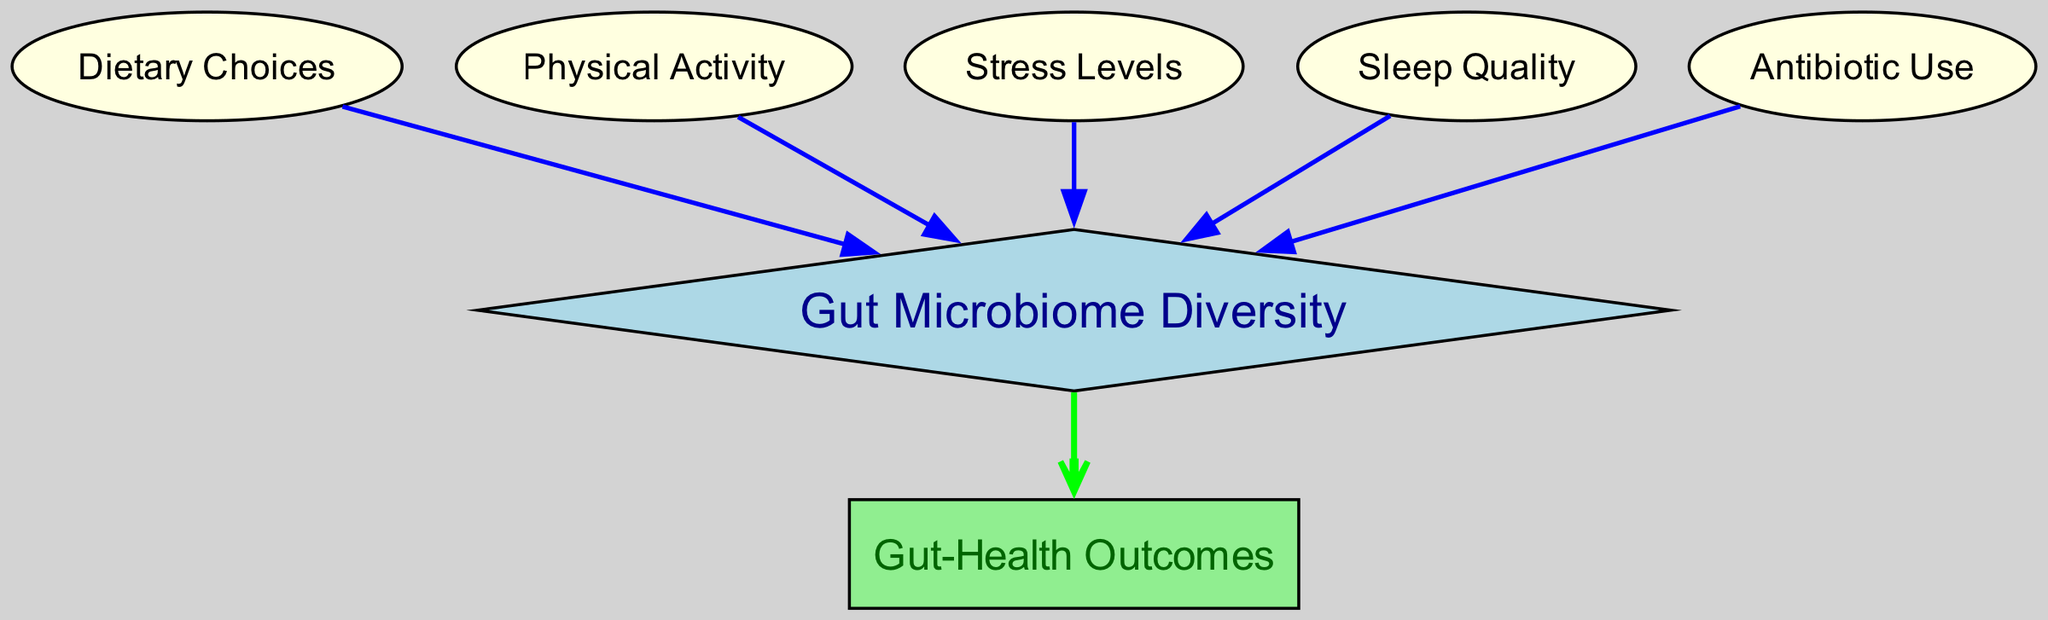What are the nodes in the diagram? The nodes in the diagram are Gut Microbiome Diversity, Dietary Choices, Physical Activity, Stress Levels, Sleep Quality, Antibiotic Use, and Gut-Health Outcomes.
Answer: Gut Microbiome Diversity, Dietary Choices, Physical Activity, Stress Levels, Sleep Quality, Antibiotic Use, Gut-Health Outcomes How many edges are present in the diagram? By counting the edges shown in the diagram, we find there are six connections made between the nodes.
Answer: 6 Which node affects Gut Microbiome Diversity the most? Since all nodes except Gut-Health Outcomes directly connect to Gut Microbiome Diversity, they all contribute equally to its diversity. However, reasoning through lifestyle factors suggests Diet choices likely have the most prominent impact.
Answer: Dietary Choices Which node is the output of Gut Microbiome Diversity? The edge directed away from Gut Microbiome Diversity leads to Gut-Health Outcomes, indicating the relationship where Gut Microbiome Diversity impacts Gut-Health Outcomes.
Answer: Gut-Health Outcomes How many lifestyle factors are considered in the diagram? There are four lifestyle factors displayed in the diagram, namely Dietary Choices, Physical Activity, Stress Levels, and Sleep Quality.
Answer: 4 What is the direction of influence from Antibiotic Use to Gut Microbiome Diversity? The influence is directed from Antibiotic Use to Gut Microbiome Diversity as represented by the edge leading to Gut Microbiome Diversity.
Answer: Downward Which nodes have a direct influence on Gut-Health Outcomes? The only node directly influencing Gut-Health Outcomes is Gut Microbiome Diversity as indicated by the edge leading from it to Gut-Health Outcomes.
Answer: Gut Microbiome Diversity Are there any lifestyle factors that have no outgoing edges? Yes, the nodes representing lifestyle factors, which influence Gut Microbiome Diversity, do not have outgoing edges leading to other factors.
Answer: Yes 